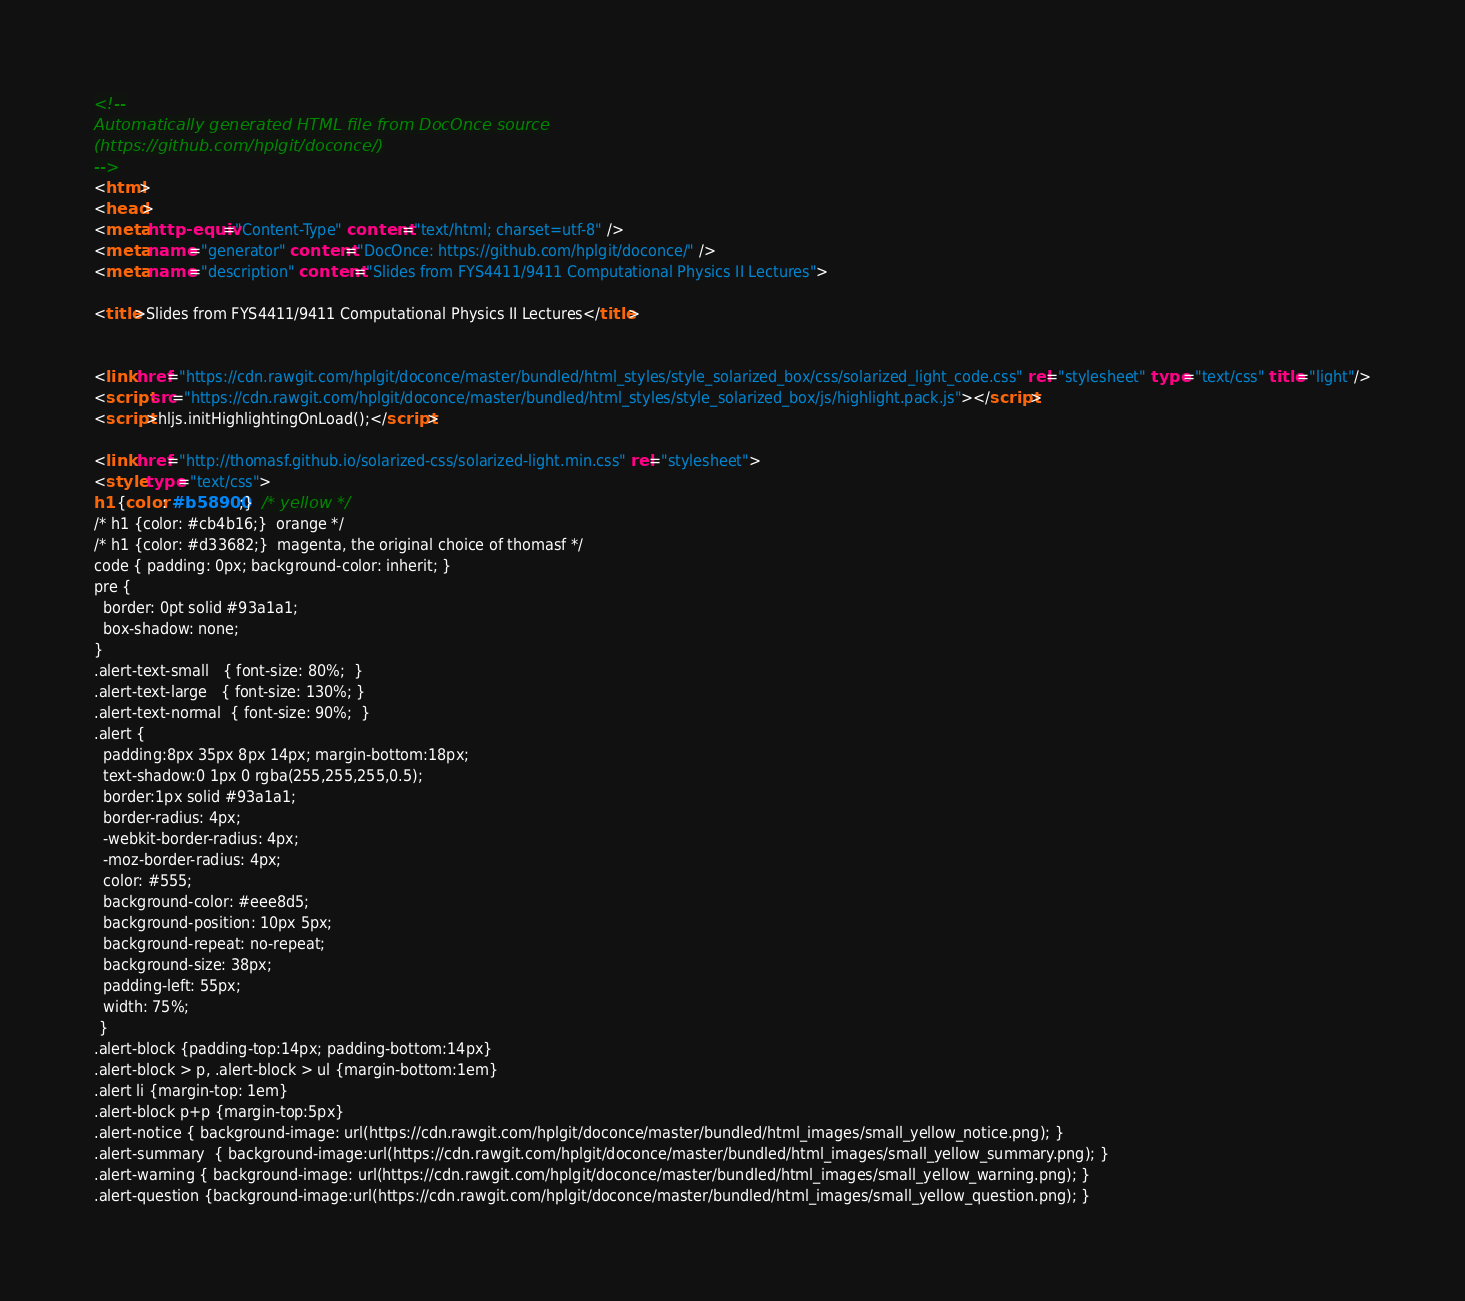<code> <loc_0><loc_0><loc_500><loc_500><_HTML_><!--
Automatically generated HTML file from DocOnce source
(https://github.com/hplgit/doconce/)
-->
<html>
<head>
<meta http-equiv="Content-Type" content="text/html; charset=utf-8" />
<meta name="generator" content="DocOnce: https://github.com/hplgit/doconce/" />
<meta name="description" content="Slides from FYS4411/9411 Computational Physics II Lectures">

<title>Slides from FYS4411/9411 Computational Physics II Lectures</title>


<link href="https://cdn.rawgit.com/hplgit/doconce/master/bundled/html_styles/style_solarized_box/css/solarized_light_code.css" rel="stylesheet" type="text/css" title="light"/>
<script src="https://cdn.rawgit.com/hplgit/doconce/master/bundled/html_styles/style_solarized_box/js/highlight.pack.js"></script>
<script>hljs.initHighlightingOnLoad();</script>

<link href="http://thomasf.github.io/solarized-css/solarized-light.min.css" rel="stylesheet">
<style type="text/css">
h1 {color: #b58900;}  /* yellow */
/* h1 {color: #cb4b16;}  orange */
/* h1 {color: #d33682;}  magenta, the original choice of thomasf */
code { padding: 0px; background-color: inherit; }
pre {
  border: 0pt solid #93a1a1;
  box-shadow: none;
}
.alert-text-small   { font-size: 80%;  }
.alert-text-large   { font-size: 130%; }
.alert-text-normal  { font-size: 90%;  }
.alert {
  padding:8px 35px 8px 14px; margin-bottom:18px;
  text-shadow:0 1px 0 rgba(255,255,255,0.5);
  border:1px solid #93a1a1;
  border-radius: 4px;
  -webkit-border-radius: 4px;
  -moz-border-radius: 4px;
  color: #555;
  background-color: #eee8d5;
  background-position: 10px 5px;
  background-repeat: no-repeat;
  background-size: 38px;
  padding-left: 55px;
  width: 75%;
 }
.alert-block {padding-top:14px; padding-bottom:14px}
.alert-block > p, .alert-block > ul {margin-bottom:1em}
.alert li {margin-top: 1em}
.alert-block p+p {margin-top:5px}
.alert-notice { background-image: url(https://cdn.rawgit.com/hplgit/doconce/master/bundled/html_images/small_yellow_notice.png); }
.alert-summary  { background-image:url(https://cdn.rawgit.com/hplgit/doconce/master/bundled/html_images/small_yellow_summary.png); }
.alert-warning { background-image: url(https://cdn.rawgit.com/hplgit/doconce/master/bundled/html_images/small_yellow_warning.png); }
.alert-question {background-image:url(https://cdn.rawgit.com/hplgit/doconce/master/bundled/html_images/small_yellow_question.png); }
</code> 